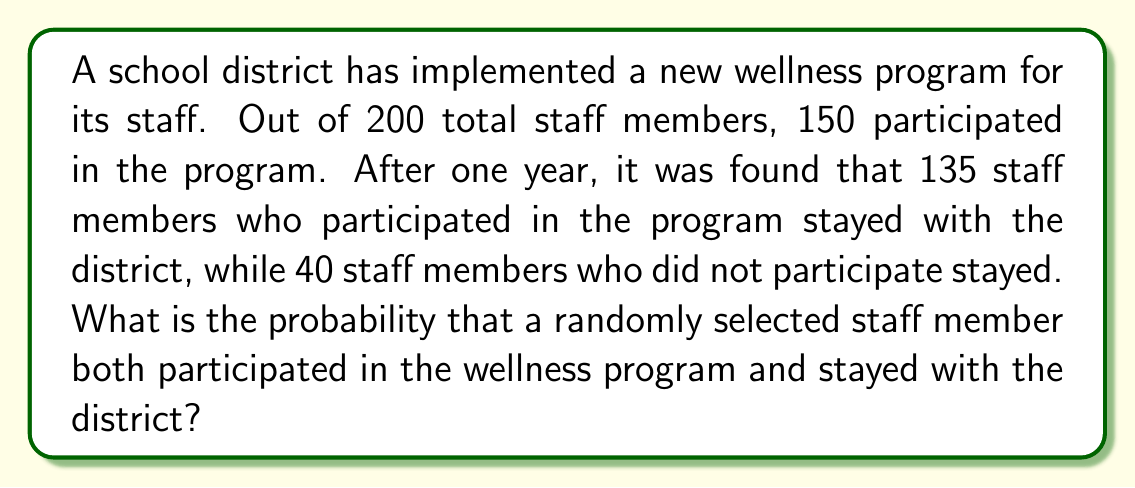Teach me how to tackle this problem. Let's approach this step-by-step:

1) First, let's define our events:
   A: Staff member participated in the wellness program
   B: Staff member stayed with the district

2) We need to find P(A ∩ B), the probability of both A and B occurring.

3) We're given the following information:
   - Total staff members: 200
   - Staff who participated in the program: 150
   - Staff who participated and stayed: 135

4) To calculate P(A ∩ B), we use:

   $$P(A \cap B) = \frac{\text{Number of staff who participated and stayed}}{\text{Total number of staff}}$$

5) Substituting the values:

   $$P(A \cap B) = \frac{135}{200}$$

6) Simplifying:

   $$P(A \cap B) = \frac{27}{40} = 0.675$$

Therefore, the probability that a randomly selected staff member both participated in the wellness program and stayed with the district is 0.675 or 67.5%.
Answer: $\frac{27}{40}$ or $0.675$ or $67.5\%$ 